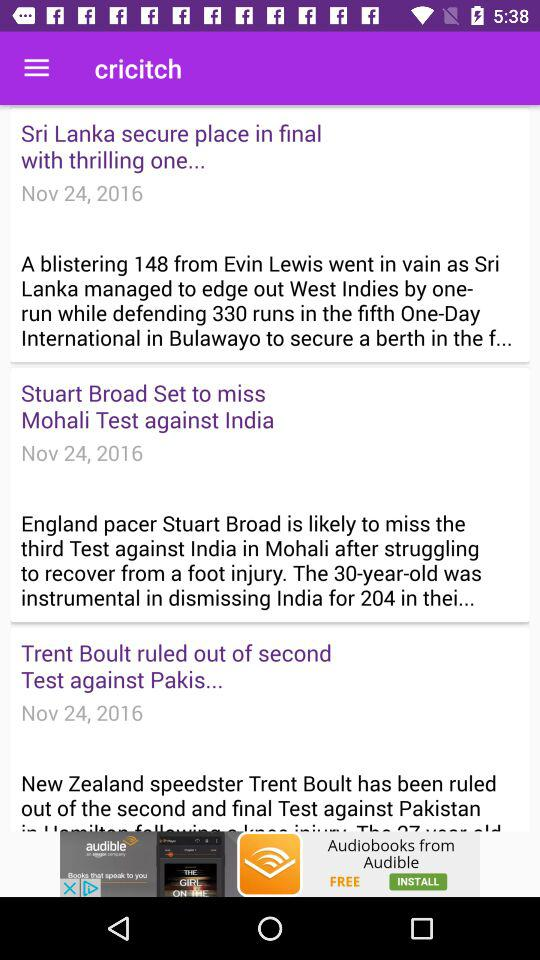What is the date of the "South Africa" and "Australia" match? The date of the "South Africa" and "Australia" match is from November 24, 2016 to November 28, 2016. 